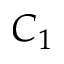<formula> <loc_0><loc_0><loc_500><loc_500>C _ { 1 }</formula> 